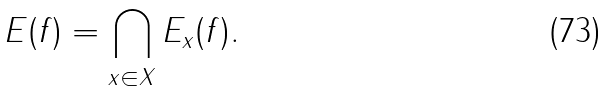<formula> <loc_0><loc_0><loc_500><loc_500>E ( f ) = \bigcap _ { x \in X } E _ { x } ( f ) .</formula> 